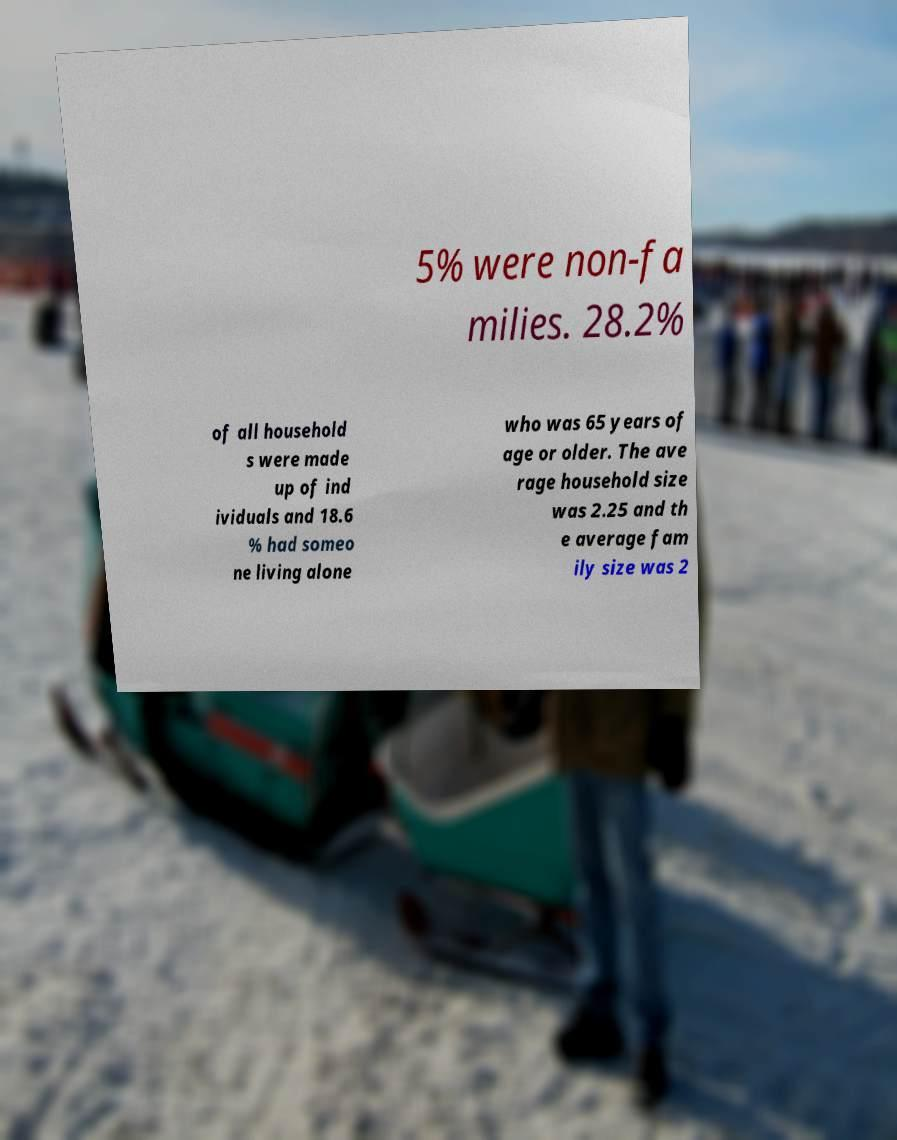There's text embedded in this image that I need extracted. Can you transcribe it verbatim? 5% were non-fa milies. 28.2% of all household s were made up of ind ividuals and 18.6 % had someo ne living alone who was 65 years of age or older. The ave rage household size was 2.25 and th e average fam ily size was 2 